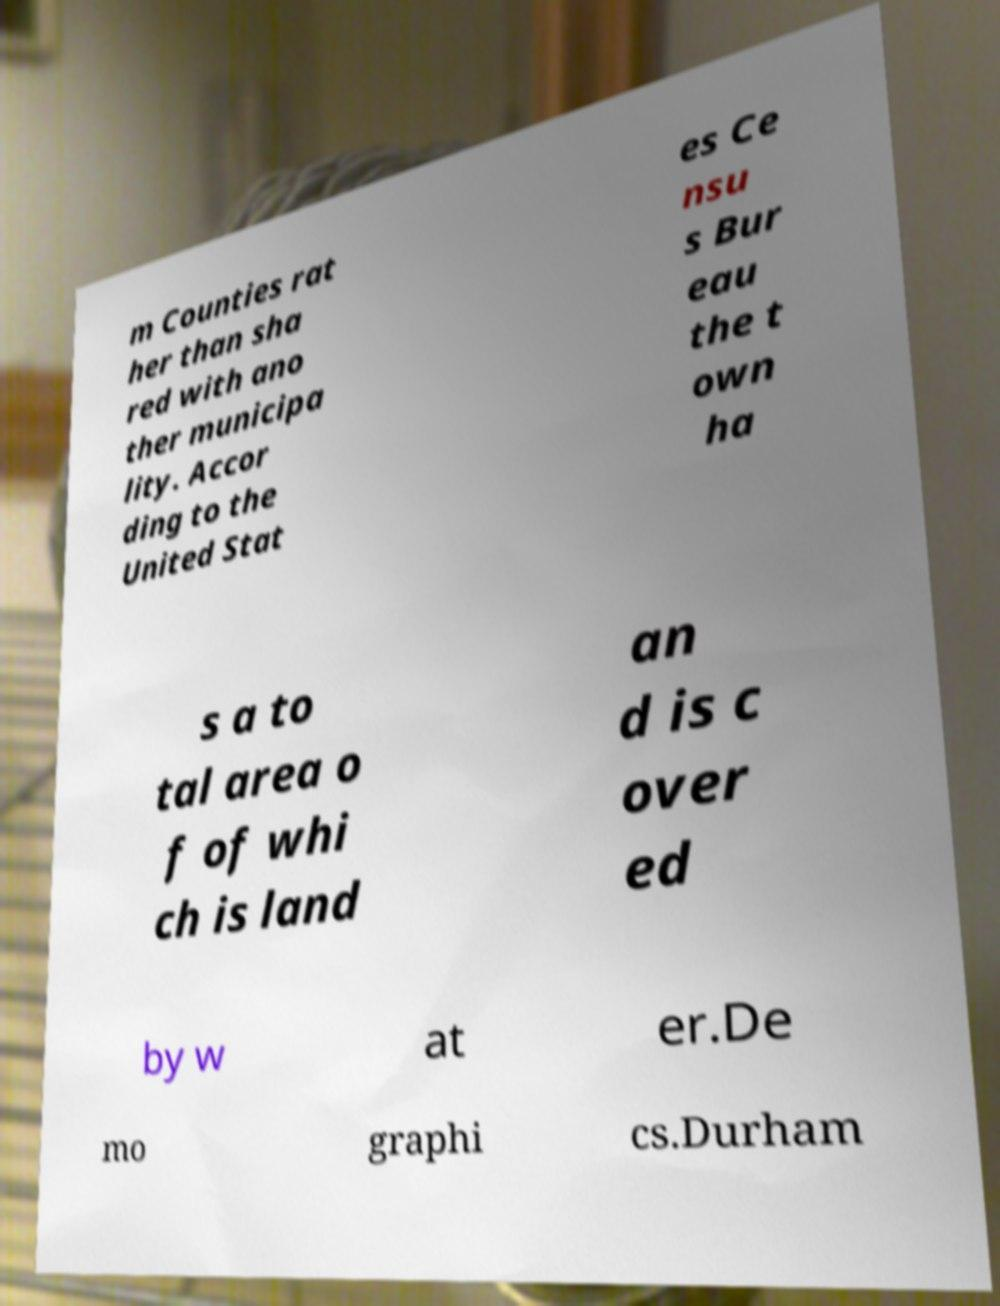I need the written content from this picture converted into text. Can you do that? m Counties rat her than sha red with ano ther municipa lity. Accor ding to the United Stat es Ce nsu s Bur eau the t own ha s a to tal area o f of whi ch is land an d is c over ed by w at er.De mo graphi cs.Durham 